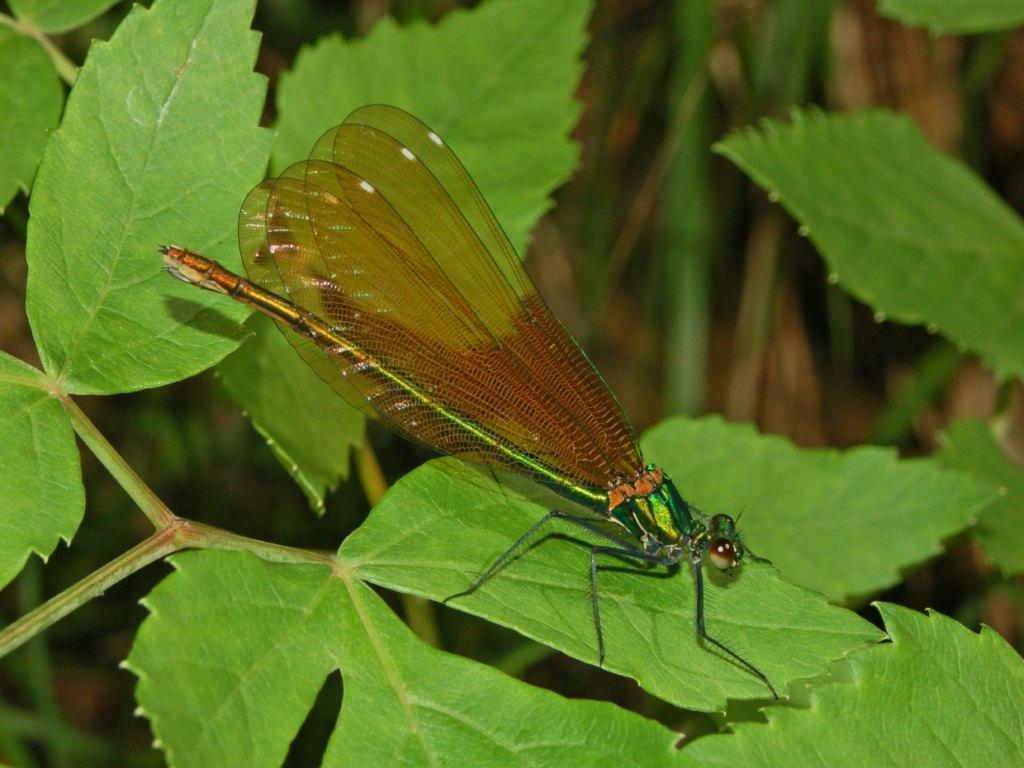What insect is present in the image? There is a dragonfly in the image. Where is the dragonfly located? The dragonfly is on a leaf. What is the color of the leaf? The leaf is green in color. What type of ornament is hanging from the dragonfly's leg in the image? There is no ornament hanging from the dragonfly's leg in the image; it is simply a dragonfly on a leaf. 